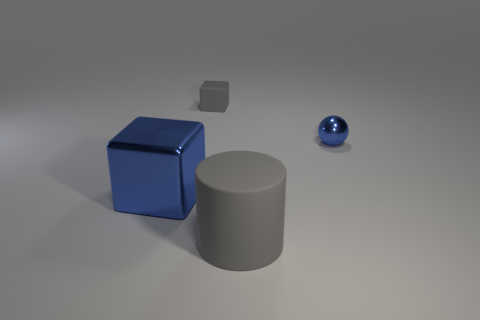Add 2 small brown metallic cubes. How many objects exist? 6 Subtract 1 spheres. How many spheres are left? 0 Subtract all cyan cubes. Subtract all purple cylinders. How many cubes are left? 2 Subtract all purple balls. How many blue cubes are left? 1 Subtract all blue rubber cylinders. Subtract all blue shiny objects. How many objects are left? 2 Add 1 tiny cubes. How many tiny cubes are left? 2 Add 4 tiny cubes. How many tiny cubes exist? 5 Subtract 0 green cubes. How many objects are left? 4 Subtract all cylinders. How many objects are left? 3 